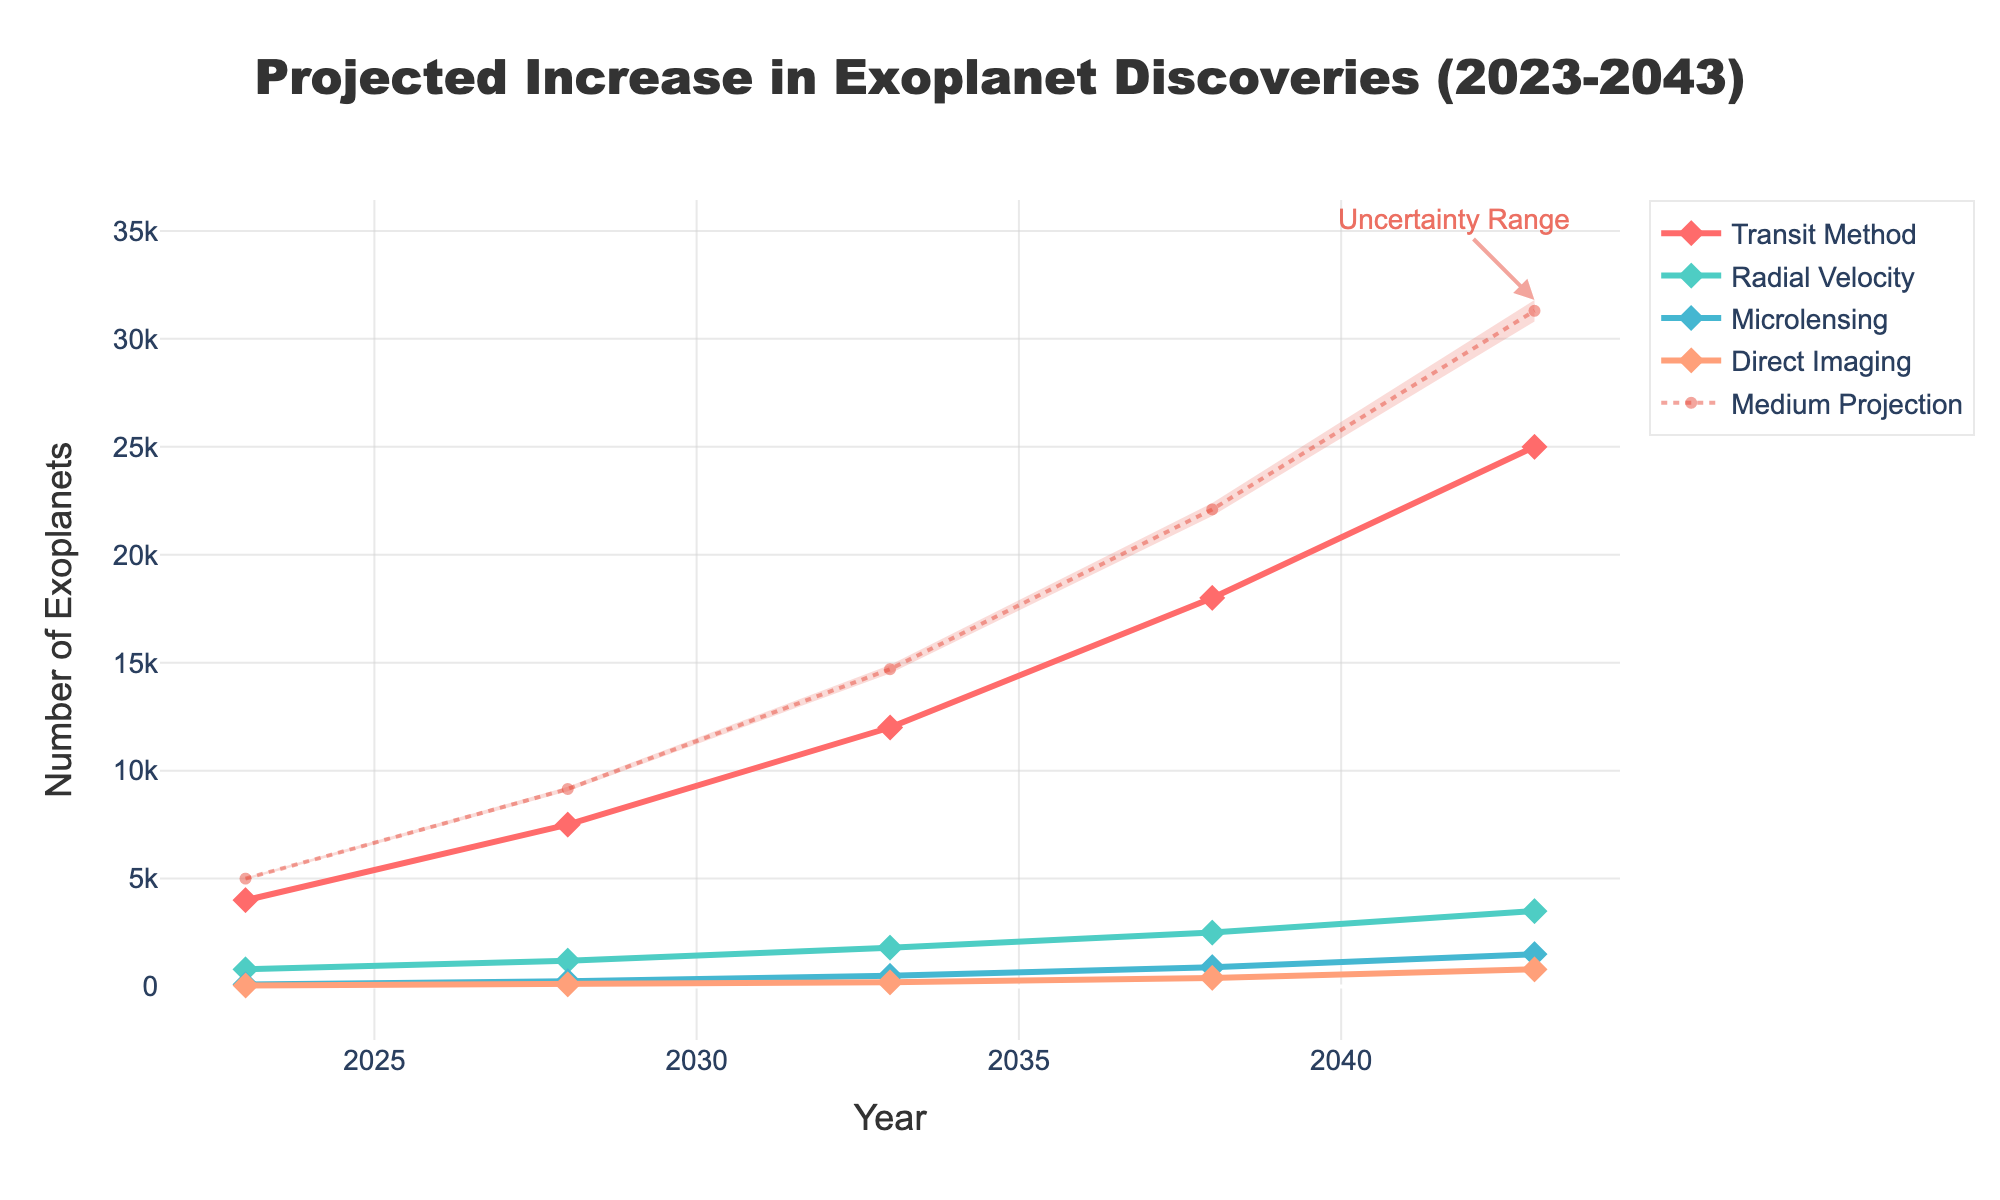What is the title of the figure? The title of the figure is usually written at the top of the chart. By reading the heading text at the very top, we see it says "Projected Increase in Exoplanet Discoveries (2023-2043)"
Answer: Projected Increase in Exoplanet Discoveries (2023-2043) How many discovery methods are shown in the figure? By looking at the legend or identifying the distinct lines with markers in different colors, we can count the number of discovery methods represented. There are four distinct lines, each corresponding to a different discovery method.
Answer: Four What is the projected number of exoplanet discoveries by the Transit Method in 2038? Locate the year 2038 on the x-axis and find the corresponding y-axis value for the Transit Method (marked with a specific color and symbol). The data shows the Transit Method at 18,000 discoveries.
Answer: 18,000 What is the range of uncertainty for the total number of exoplanet discoveries in 2043? Look at the fan chart's shaded area, specifically the y-axis values at the year 2043. The lower bound (Low) is 30,800, and the upper bound (High) is 31,800.
Answer: 30,800 to 31,800 Which discovery method shows the highest growth from 2023 to 2043? By comparing the vertical distance each method travels between 2023 and 2043, we see that the Transit Method goes from 4,000 to 25,000, showing the largest increase.
Answer: Transit Method What is the difference between the High and Low projections for 2043? Find the High (31,800) and Low (30,800) projections for 2043 and subtract the Low from the High: 31,800 - 30,800.
Answer: 1,000 How do the number of discoveries projected in 2033 compare between the Radial Velocity and Microlensing methods? Locate the year 2033 on the x-axis, then compare the y-axis values for Radial Velocity (1,800) and Microlensing (500). Radial Velocity has more discoveries.
Answer: Radial Velocity is higher What does the shaded area in the chart represent? The shaded area, or the fan, encompasses the uncertainty range around the projections. It fills the space from the Low projection to the High projection over the years displayed.
Answer: Uncertainty range What is the medium projection of total exoplanet discoveries in 2028? Follow the dotted line labeled "Medium Projection" to the year 2028. The y-axis value for this projection is listed as 9,150.
Answer: 9,150 How many more exoplanets are projected to be discovered using Direct Imaging in 2043 compared to 2023? Find the y-axis values for Direct Imaging in 2043 (800) and 2023 (50). Subtract the 2023 value from the 2043 value: 800 - 50.
Answer: 750 